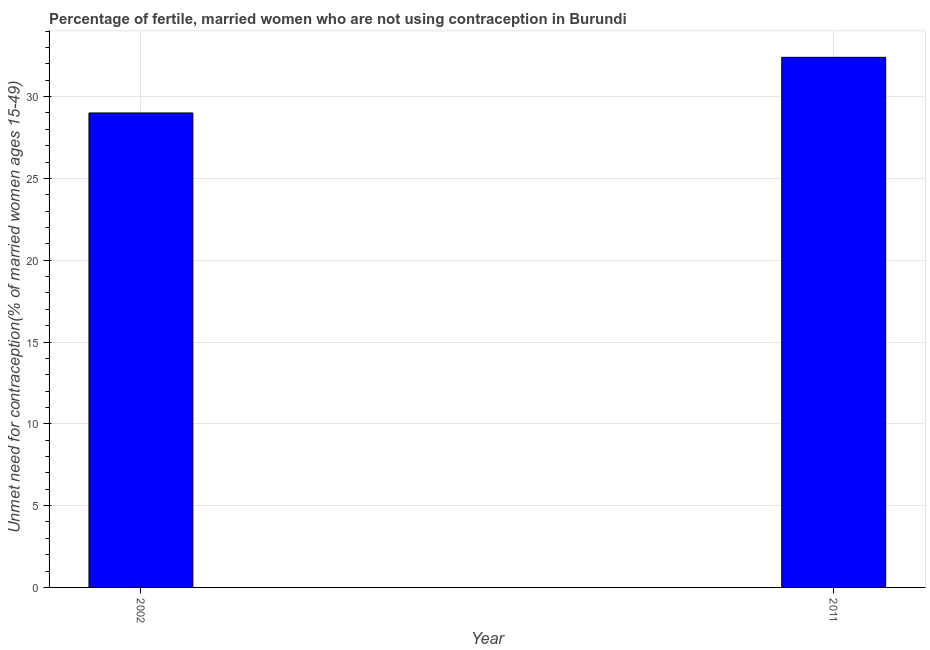Does the graph contain any zero values?
Make the answer very short. No. What is the title of the graph?
Ensure brevity in your answer.  Percentage of fertile, married women who are not using contraception in Burundi. What is the label or title of the X-axis?
Provide a succinct answer. Year. What is the label or title of the Y-axis?
Your answer should be compact.  Unmet need for contraception(% of married women ages 15-49). What is the number of married women who are not using contraception in 2011?
Make the answer very short. 32.4. Across all years, what is the maximum number of married women who are not using contraception?
Offer a very short reply. 32.4. In which year was the number of married women who are not using contraception maximum?
Your answer should be compact. 2011. What is the sum of the number of married women who are not using contraception?
Keep it short and to the point. 61.4. What is the difference between the number of married women who are not using contraception in 2002 and 2011?
Provide a short and direct response. -3.4. What is the average number of married women who are not using contraception per year?
Keep it short and to the point. 30.7. What is the median number of married women who are not using contraception?
Keep it short and to the point. 30.7. In how many years, is the number of married women who are not using contraception greater than 22 %?
Offer a terse response. 2. Do a majority of the years between 2002 and 2011 (inclusive) have number of married women who are not using contraception greater than 26 %?
Offer a very short reply. Yes. What is the ratio of the number of married women who are not using contraception in 2002 to that in 2011?
Keep it short and to the point. 0.9. Is the number of married women who are not using contraception in 2002 less than that in 2011?
Ensure brevity in your answer.  Yes. In how many years, is the number of married women who are not using contraception greater than the average number of married women who are not using contraception taken over all years?
Offer a very short reply. 1. How many years are there in the graph?
Offer a very short reply. 2. What is the difference between two consecutive major ticks on the Y-axis?
Provide a short and direct response. 5. Are the values on the major ticks of Y-axis written in scientific E-notation?
Provide a succinct answer. No. What is the  Unmet need for contraception(% of married women ages 15-49) of 2011?
Provide a short and direct response. 32.4. What is the ratio of the  Unmet need for contraception(% of married women ages 15-49) in 2002 to that in 2011?
Your answer should be very brief. 0.9. 